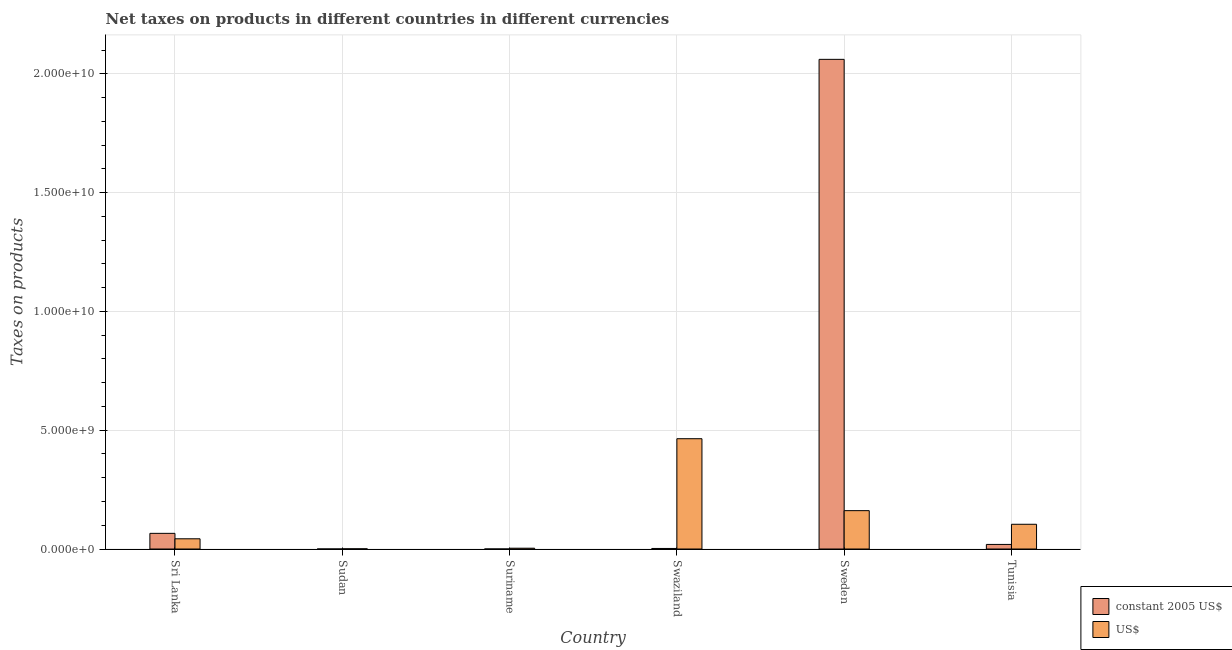How many groups of bars are there?
Offer a terse response. 6. How many bars are there on the 5th tick from the left?
Make the answer very short. 2. What is the label of the 6th group of bars from the left?
Provide a short and direct response. Tunisia. What is the net taxes in us$ in Suriname?
Offer a very short reply. 3.36e+07. Across all countries, what is the maximum net taxes in constant 2005 us$?
Offer a very short reply. 2.06e+1. Across all countries, what is the minimum net taxes in us$?
Keep it short and to the point. 7.45e+06. In which country was the net taxes in us$ maximum?
Offer a very short reply. Swaziland. In which country was the net taxes in us$ minimum?
Ensure brevity in your answer.  Sudan. What is the total net taxes in us$ in the graph?
Keep it short and to the point. 7.77e+09. What is the difference between the net taxes in constant 2005 us$ in Sri Lanka and that in Tunisia?
Keep it short and to the point. 4.66e+08. What is the difference between the net taxes in us$ in Swaziland and the net taxes in constant 2005 us$ in Sri Lanka?
Provide a short and direct response. 3.98e+09. What is the average net taxes in constant 2005 us$ per country?
Your answer should be very brief. 3.58e+09. What is the difference between the net taxes in us$ and net taxes in constant 2005 us$ in Sweden?
Your response must be concise. -1.90e+1. What is the ratio of the net taxes in constant 2005 us$ in Sudan to that in Swaziland?
Offer a terse response. 0.01. Is the difference between the net taxes in us$ in Sri Lanka and Sweden greater than the difference between the net taxes in constant 2005 us$ in Sri Lanka and Sweden?
Your answer should be compact. Yes. What is the difference between the highest and the second highest net taxes in us$?
Provide a short and direct response. 3.03e+09. What is the difference between the highest and the lowest net taxes in us$?
Ensure brevity in your answer.  4.63e+09. In how many countries, is the net taxes in constant 2005 us$ greater than the average net taxes in constant 2005 us$ taken over all countries?
Give a very brief answer. 1. What does the 2nd bar from the left in Tunisia represents?
Provide a succinct answer. US$. What does the 1st bar from the right in Suriname represents?
Your answer should be very brief. US$. How many countries are there in the graph?
Provide a succinct answer. 6. What is the difference between two consecutive major ticks on the Y-axis?
Your answer should be compact. 5.00e+09. Does the graph contain any zero values?
Your answer should be very brief. No. Where does the legend appear in the graph?
Your response must be concise. Bottom right. How are the legend labels stacked?
Provide a succinct answer. Vertical. What is the title of the graph?
Offer a terse response. Net taxes on products in different countries in different currencies. Does "Girls" appear as one of the legend labels in the graph?
Keep it short and to the point. No. What is the label or title of the X-axis?
Offer a terse response. Country. What is the label or title of the Y-axis?
Provide a succinct answer. Taxes on products. What is the Taxes on products in constant 2005 US$ in Sri Lanka?
Offer a very short reply. 6.59e+08. What is the Taxes on products of US$ in Sri Lanka?
Keep it short and to the point. 4.30e+08. What is the Taxes on products in constant 2005 US$ in Sudan?
Your answer should be compact. 1.50e+05. What is the Taxes on products in US$ in Sudan?
Give a very brief answer. 7.45e+06. What is the Taxes on products of constant 2005 US$ in Suriname?
Your response must be concise. 1.49e+04. What is the Taxes on products in US$ in Suriname?
Make the answer very short. 3.36e+07. What is the Taxes on products of constant 2005 US$ in Swaziland?
Provide a succinct answer. 2.28e+07. What is the Taxes on products of US$ in Swaziland?
Offer a very short reply. 4.64e+09. What is the Taxes on products in constant 2005 US$ in Sweden?
Provide a succinct answer. 2.06e+1. What is the Taxes on products in US$ in Sweden?
Offer a terse response. 1.61e+09. What is the Taxes on products of constant 2005 US$ in Tunisia?
Offer a terse response. 1.93e+08. What is the Taxes on products in US$ in Tunisia?
Make the answer very short. 1.04e+09. Across all countries, what is the maximum Taxes on products in constant 2005 US$?
Provide a short and direct response. 2.06e+1. Across all countries, what is the maximum Taxes on products in US$?
Offer a very short reply. 4.64e+09. Across all countries, what is the minimum Taxes on products in constant 2005 US$?
Keep it short and to the point. 1.49e+04. Across all countries, what is the minimum Taxes on products in US$?
Keep it short and to the point. 7.45e+06. What is the total Taxes on products of constant 2005 US$ in the graph?
Give a very brief answer. 2.15e+1. What is the total Taxes on products of US$ in the graph?
Give a very brief answer. 7.77e+09. What is the difference between the Taxes on products of constant 2005 US$ in Sri Lanka and that in Sudan?
Provide a short and direct response. 6.59e+08. What is the difference between the Taxes on products of US$ in Sri Lanka and that in Sudan?
Your answer should be compact. 4.22e+08. What is the difference between the Taxes on products of constant 2005 US$ in Sri Lanka and that in Suriname?
Provide a short and direct response. 6.59e+08. What is the difference between the Taxes on products in US$ in Sri Lanka and that in Suriname?
Offer a very short reply. 3.96e+08. What is the difference between the Taxes on products in constant 2005 US$ in Sri Lanka and that in Swaziland?
Provide a succinct answer. 6.36e+08. What is the difference between the Taxes on products of US$ in Sri Lanka and that in Swaziland?
Your answer should be very brief. -4.21e+09. What is the difference between the Taxes on products in constant 2005 US$ in Sri Lanka and that in Sweden?
Give a very brief answer. -2.00e+1. What is the difference between the Taxes on products in US$ in Sri Lanka and that in Sweden?
Give a very brief answer. -1.19e+09. What is the difference between the Taxes on products of constant 2005 US$ in Sri Lanka and that in Tunisia?
Offer a terse response. 4.66e+08. What is the difference between the Taxes on products in US$ in Sri Lanka and that in Tunisia?
Your answer should be very brief. -6.12e+08. What is the difference between the Taxes on products of constant 2005 US$ in Sudan and that in Suriname?
Provide a short and direct response. 1.35e+05. What is the difference between the Taxes on products in US$ in Sudan and that in Suriname?
Offer a terse response. -2.61e+07. What is the difference between the Taxes on products in constant 2005 US$ in Sudan and that in Swaziland?
Your answer should be compact. -2.27e+07. What is the difference between the Taxes on products of US$ in Sudan and that in Swaziland?
Keep it short and to the point. -4.63e+09. What is the difference between the Taxes on products of constant 2005 US$ in Sudan and that in Sweden?
Ensure brevity in your answer.  -2.06e+1. What is the difference between the Taxes on products of US$ in Sudan and that in Sweden?
Provide a succinct answer. -1.61e+09. What is the difference between the Taxes on products in constant 2005 US$ in Sudan and that in Tunisia?
Offer a terse response. -1.92e+08. What is the difference between the Taxes on products of US$ in Sudan and that in Tunisia?
Your answer should be very brief. -1.03e+09. What is the difference between the Taxes on products in constant 2005 US$ in Suriname and that in Swaziland?
Offer a very short reply. -2.28e+07. What is the difference between the Taxes on products in US$ in Suriname and that in Swaziland?
Ensure brevity in your answer.  -4.61e+09. What is the difference between the Taxes on products in constant 2005 US$ in Suriname and that in Sweden?
Your response must be concise. -2.06e+1. What is the difference between the Taxes on products in US$ in Suriname and that in Sweden?
Provide a short and direct response. -1.58e+09. What is the difference between the Taxes on products in constant 2005 US$ in Suriname and that in Tunisia?
Ensure brevity in your answer.  -1.93e+08. What is the difference between the Taxes on products in US$ in Suriname and that in Tunisia?
Offer a terse response. -1.01e+09. What is the difference between the Taxes on products of constant 2005 US$ in Swaziland and that in Sweden?
Offer a terse response. -2.06e+1. What is the difference between the Taxes on products of US$ in Swaziland and that in Sweden?
Keep it short and to the point. 3.03e+09. What is the difference between the Taxes on products of constant 2005 US$ in Swaziland and that in Tunisia?
Offer a terse response. -1.70e+08. What is the difference between the Taxes on products of US$ in Swaziland and that in Tunisia?
Provide a succinct answer. 3.60e+09. What is the difference between the Taxes on products in constant 2005 US$ in Sweden and that in Tunisia?
Offer a terse response. 2.04e+1. What is the difference between the Taxes on products of US$ in Sweden and that in Tunisia?
Make the answer very short. 5.74e+08. What is the difference between the Taxes on products of constant 2005 US$ in Sri Lanka and the Taxes on products of US$ in Sudan?
Make the answer very short. 6.52e+08. What is the difference between the Taxes on products of constant 2005 US$ in Sri Lanka and the Taxes on products of US$ in Suriname?
Make the answer very short. 6.25e+08. What is the difference between the Taxes on products of constant 2005 US$ in Sri Lanka and the Taxes on products of US$ in Swaziland?
Ensure brevity in your answer.  -3.98e+09. What is the difference between the Taxes on products in constant 2005 US$ in Sri Lanka and the Taxes on products in US$ in Sweden?
Offer a terse response. -9.56e+08. What is the difference between the Taxes on products in constant 2005 US$ in Sri Lanka and the Taxes on products in US$ in Tunisia?
Give a very brief answer. -3.82e+08. What is the difference between the Taxes on products of constant 2005 US$ in Sudan and the Taxes on products of US$ in Suriname?
Ensure brevity in your answer.  -3.34e+07. What is the difference between the Taxes on products of constant 2005 US$ in Sudan and the Taxes on products of US$ in Swaziland?
Ensure brevity in your answer.  -4.64e+09. What is the difference between the Taxes on products of constant 2005 US$ in Sudan and the Taxes on products of US$ in Sweden?
Give a very brief answer. -1.61e+09. What is the difference between the Taxes on products in constant 2005 US$ in Sudan and the Taxes on products in US$ in Tunisia?
Keep it short and to the point. -1.04e+09. What is the difference between the Taxes on products in constant 2005 US$ in Suriname and the Taxes on products in US$ in Swaziland?
Make the answer very short. -4.64e+09. What is the difference between the Taxes on products in constant 2005 US$ in Suriname and the Taxes on products in US$ in Sweden?
Provide a succinct answer. -1.61e+09. What is the difference between the Taxes on products in constant 2005 US$ in Suriname and the Taxes on products in US$ in Tunisia?
Ensure brevity in your answer.  -1.04e+09. What is the difference between the Taxes on products in constant 2005 US$ in Swaziland and the Taxes on products in US$ in Sweden?
Provide a short and direct response. -1.59e+09. What is the difference between the Taxes on products in constant 2005 US$ in Swaziland and the Taxes on products in US$ in Tunisia?
Keep it short and to the point. -1.02e+09. What is the difference between the Taxes on products of constant 2005 US$ in Sweden and the Taxes on products of US$ in Tunisia?
Keep it short and to the point. 1.96e+1. What is the average Taxes on products of constant 2005 US$ per country?
Your response must be concise. 3.58e+09. What is the average Taxes on products in US$ per country?
Provide a succinct answer. 1.29e+09. What is the difference between the Taxes on products of constant 2005 US$ and Taxes on products of US$ in Sri Lanka?
Your answer should be very brief. 2.29e+08. What is the difference between the Taxes on products in constant 2005 US$ and Taxes on products in US$ in Sudan?
Your answer should be very brief. -7.30e+06. What is the difference between the Taxes on products of constant 2005 US$ and Taxes on products of US$ in Suriname?
Offer a terse response. -3.35e+07. What is the difference between the Taxes on products of constant 2005 US$ and Taxes on products of US$ in Swaziland?
Ensure brevity in your answer.  -4.62e+09. What is the difference between the Taxes on products in constant 2005 US$ and Taxes on products in US$ in Sweden?
Offer a terse response. 1.90e+1. What is the difference between the Taxes on products of constant 2005 US$ and Taxes on products of US$ in Tunisia?
Keep it short and to the point. -8.49e+08. What is the ratio of the Taxes on products in constant 2005 US$ in Sri Lanka to that in Sudan?
Offer a terse response. 4405.08. What is the ratio of the Taxes on products in US$ in Sri Lanka to that in Sudan?
Your answer should be very brief. 57.67. What is the ratio of the Taxes on products of constant 2005 US$ in Sri Lanka to that in Suriname?
Your answer should be very brief. 4.42e+04. What is the ratio of the Taxes on products of US$ in Sri Lanka to that in Suriname?
Ensure brevity in your answer.  12.8. What is the ratio of the Taxes on products of constant 2005 US$ in Sri Lanka to that in Swaziland?
Give a very brief answer. 28.9. What is the ratio of the Taxes on products in US$ in Sri Lanka to that in Swaziland?
Give a very brief answer. 0.09. What is the ratio of the Taxes on products in constant 2005 US$ in Sri Lanka to that in Sweden?
Your answer should be compact. 0.03. What is the ratio of the Taxes on products in US$ in Sri Lanka to that in Sweden?
Offer a very short reply. 0.27. What is the ratio of the Taxes on products of constant 2005 US$ in Sri Lanka to that in Tunisia?
Make the answer very short. 3.42. What is the ratio of the Taxes on products of US$ in Sri Lanka to that in Tunisia?
Ensure brevity in your answer.  0.41. What is the ratio of the Taxes on products of constant 2005 US$ in Sudan to that in Suriname?
Your answer should be very brief. 10.04. What is the ratio of the Taxes on products in US$ in Sudan to that in Suriname?
Ensure brevity in your answer.  0.22. What is the ratio of the Taxes on products of constant 2005 US$ in Sudan to that in Swaziland?
Provide a short and direct response. 0.01. What is the ratio of the Taxes on products in US$ in Sudan to that in Swaziland?
Offer a terse response. 0. What is the ratio of the Taxes on products of US$ in Sudan to that in Sweden?
Keep it short and to the point. 0. What is the ratio of the Taxes on products of constant 2005 US$ in Sudan to that in Tunisia?
Ensure brevity in your answer.  0. What is the ratio of the Taxes on products in US$ in Sudan to that in Tunisia?
Your response must be concise. 0.01. What is the ratio of the Taxes on products in constant 2005 US$ in Suriname to that in Swaziland?
Ensure brevity in your answer.  0. What is the ratio of the Taxes on products of US$ in Suriname to that in Swaziland?
Give a very brief answer. 0.01. What is the ratio of the Taxes on products of constant 2005 US$ in Suriname to that in Sweden?
Keep it short and to the point. 0. What is the ratio of the Taxes on products of US$ in Suriname to that in Sweden?
Provide a succinct answer. 0.02. What is the ratio of the Taxes on products of constant 2005 US$ in Suriname to that in Tunisia?
Offer a very short reply. 0. What is the ratio of the Taxes on products of US$ in Suriname to that in Tunisia?
Your answer should be compact. 0.03. What is the ratio of the Taxes on products in constant 2005 US$ in Swaziland to that in Sweden?
Your answer should be compact. 0. What is the ratio of the Taxes on products of US$ in Swaziland to that in Sweden?
Provide a succinct answer. 2.88. What is the ratio of the Taxes on products of constant 2005 US$ in Swaziland to that in Tunisia?
Offer a terse response. 0.12. What is the ratio of the Taxes on products of US$ in Swaziland to that in Tunisia?
Keep it short and to the point. 4.46. What is the ratio of the Taxes on products in constant 2005 US$ in Sweden to that in Tunisia?
Give a very brief answer. 107.01. What is the ratio of the Taxes on products of US$ in Sweden to that in Tunisia?
Give a very brief answer. 1.55. What is the difference between the highest and the second highest Taxes on products in constant 2005 US$?
Your answer should be very brief. 2.00e+1. What is the difference between the highest and the second highest Taxes on products in US$?
Give a very brief answer. 3.03e+09. What is the difference between the highest and the lowest Taxes on products in constant 2005 US$?
Your answer should be compact. 2.06e+1. What is the difference between the highest and the lowest Taxes on products in US$?
Provide a succinct answer. 4.63e+09. 